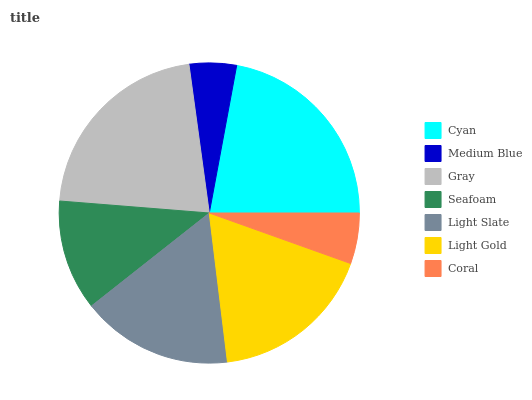Is Medium Blue the minimum?
Answer yes or no. Yes. Is Cyan the maximum?
Answer yes or no. Yes. Is Gray the minimum?
Answer yes or no. No. Is Gray the maximum?
Answer yes or no. No. Is Gray greater than Medium Blue?
Answer yes or no. Yes. Is Medium Blue less than Gray?
Answer yes or no. Yes. Is Medium Blue greater than Gray?
Answer yes or no. No. Is Gray less than Medium Blue?
Answer yes or no. No. Is Light Slate the high median?
Answer yes or no. Yes. Is Light Slate the low median?
Answer yes or no. Yes. Is Seafoam the high median?
Answer yes or no. No. Is Gray the low median?
Answer yes or no. No. 